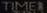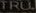Identify the words shown in these images in order, separated by a semicolon. TIMEI; TRU 